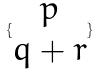<formula> <loc_0><loc_0><loc_500><loc_500>\{ \begin{matrix} p \\ q + r \end{matrix} \}</formula> 